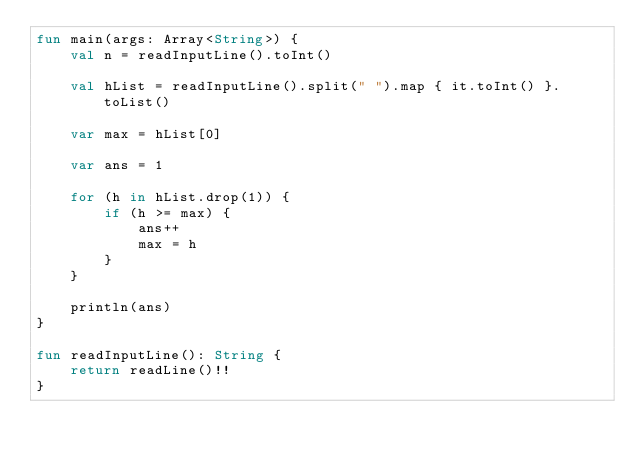<code> <loc_0><loc_0><loc_500><loc_500><_Kotlin_>fun main(args: Array<String>) {
    val n = readInputLine().toInt()
    
    val hList = readInputLine().split(" ").map { it.toInt() }.toList()
    
    var max = hList[0]
    
    var ans = 1
    
    for (h in hList.drop(1)) {
        if (h >= max) {
            ans++
            max = h
        }
    }
    
    println(ans)
}

fun readInputLine(): String {
    return readLine()!!
}
</code> 